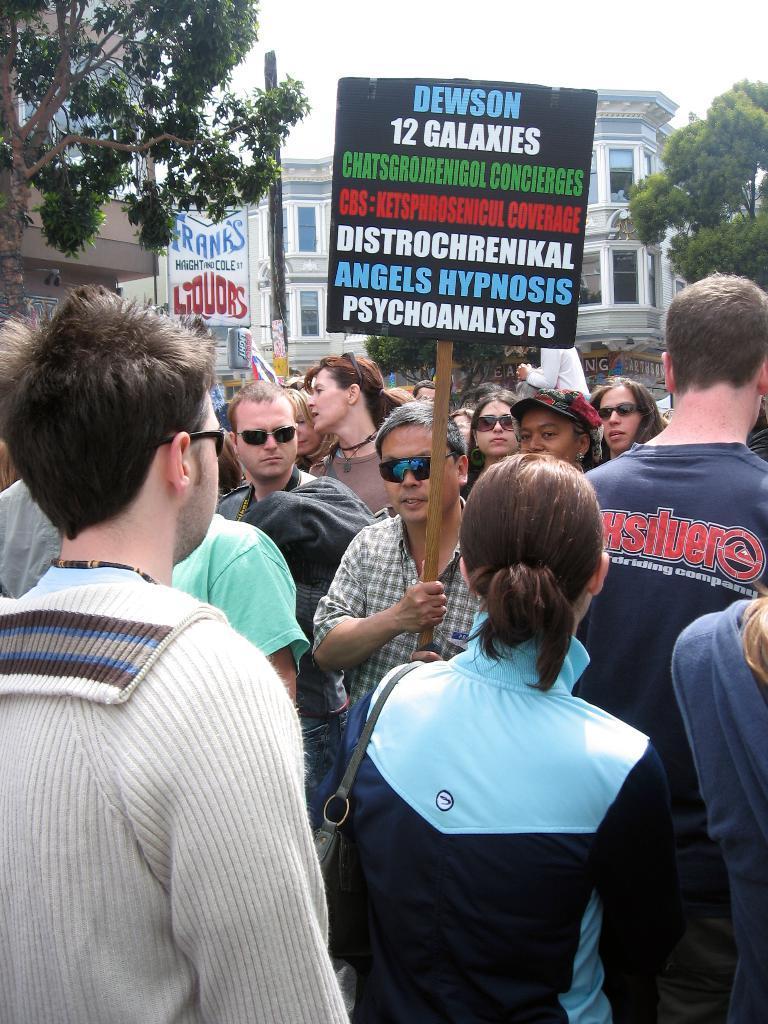Please provide a concise description of this image. In this image there is a man in the middle who is holding the placard. There are few people around him. In the background there is a building. On the right side top corner there is a tree. On the left side top there is a board and a tree. 